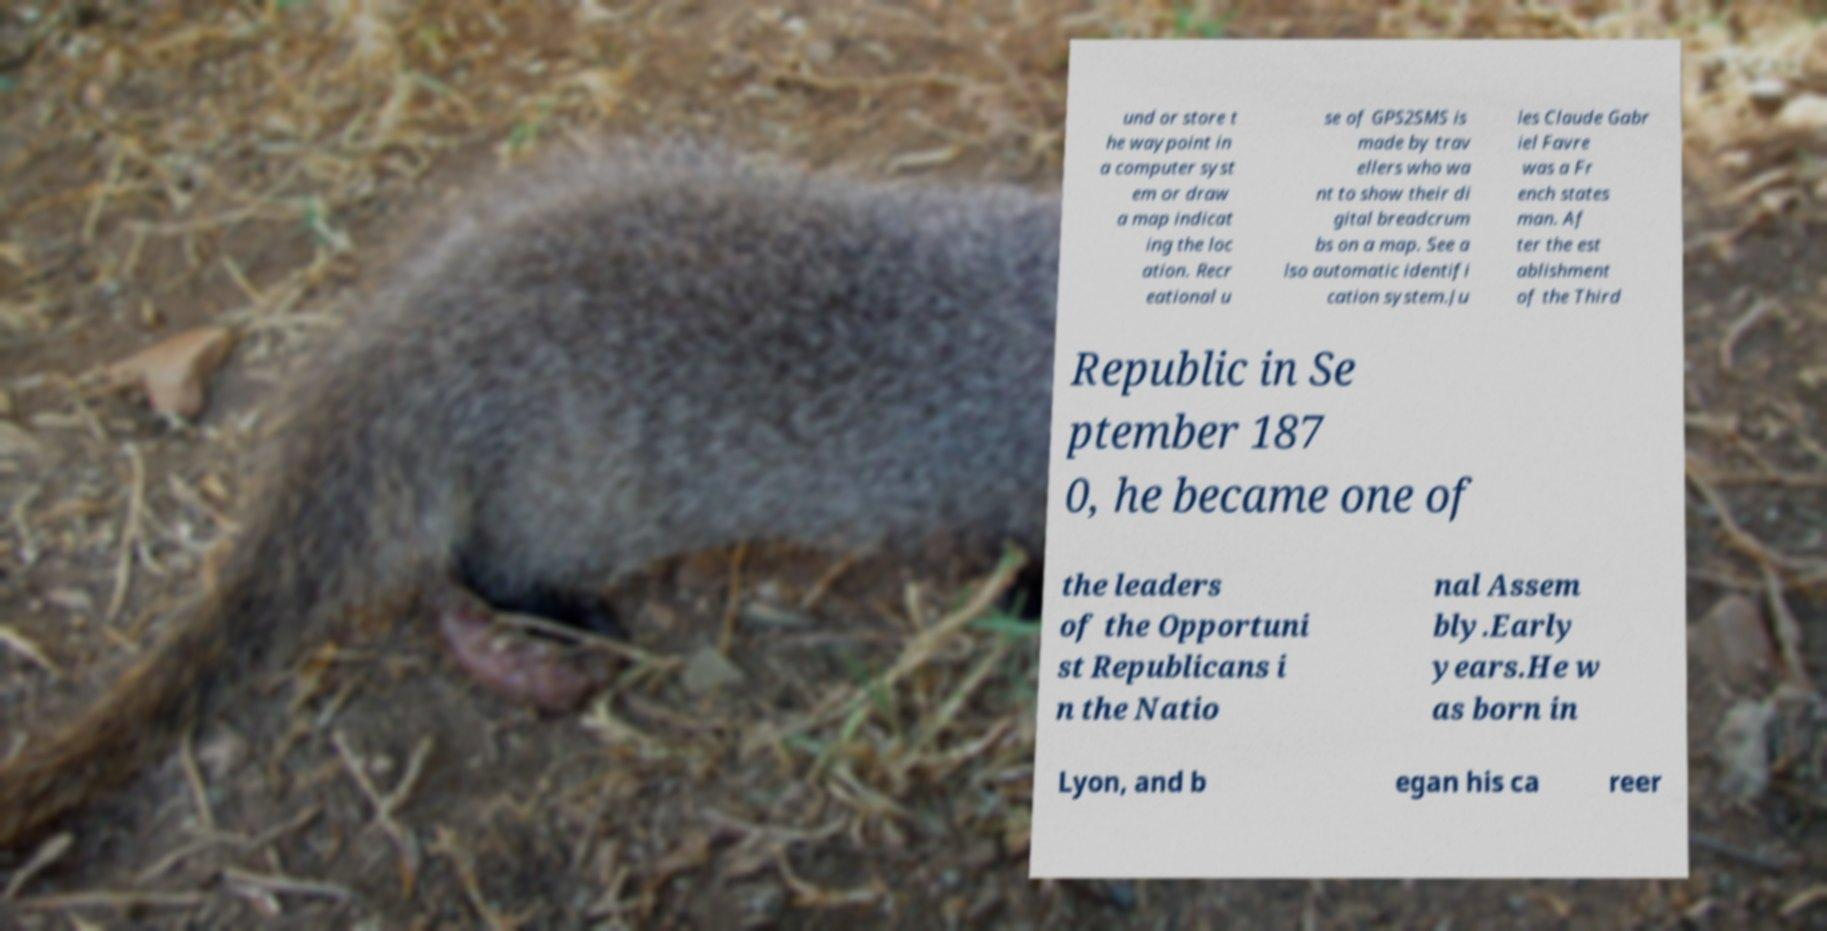Could you assist in decoding the text presented in this image and type it out clearly? und or store t he waypoint in a computer syst em or draw a map indicat ing the loc ation. Recr eational u se of GPS2SMS is made by trav ellers who wa nt to show their di gital breadcrum bs on a map. See a lso automatic identifi cation system.Ju les Claude Gabr iel Favre was a Fr ench states man. Af ter the est ablishment of the Third Republic in Se ptember 187 0, he became one of the leaders of the Opportuni st Republicans i n the Natio nal Assem bly.Early years.He w as born in Lyon, and b egan his ca reer 